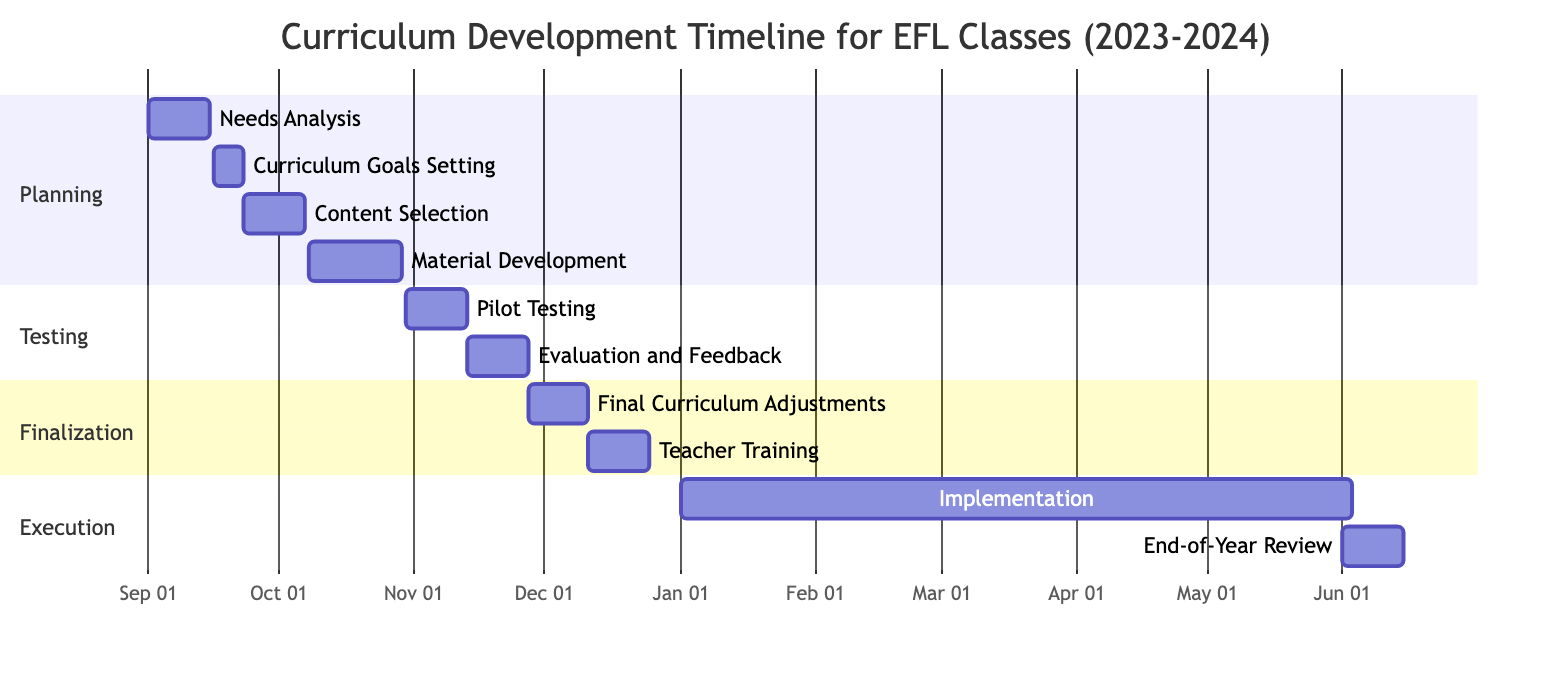What is the duration of the "Content Selection" task? The "Content Selection" task starts on September 23, 2023, and ends on October 7, 2023. This is a duration of 2 weeks.
Answer: 2 weeks When does the "Teacher Training" task begin? The "Teacher Training" task starts on December 11, 2023, according to the timeline.
Answer: December 11, 2023 Which task ends immediately before the "Pilot Testing"? According to the timeline, the "Material Development" task ends on October 29, 2023, which is immediately before the "Pilot Testing" that starts on October 30, 2023.
Answer: Material Development How many weeks are allocated for "Evaluation and Feedback"? The "Evaluation and Feedback" task spans from November 13 to November 26, 2023, which totals 2 weeks.
Answer: 2 weeks What is the total timeframe for the entire curriculum development process, from needs analysis to end-of-year review? The process begins with "Needs Analysis" on September 1, 2023, and ends with "End-of-Year Review" on June 15, 2024. This is a total duration of approximately 9.5 months (9 months and 15 days).
Answer: 9 months and 15 days Is there any overlap between "Material Development" and "Pilot Testing"? "Material Development" ends on October 29, 2023, and "Pilot Testing" begins one day later on October 30, 2023, indicating no overlap; they are sequential tasks.
Answer: No What is the section that contains the "Final Curriculum Adjustments" task? The "Final Curriculum Adjustments" task is located in the "Finalization" section of the Gantt Chart.
Answer: Finalization Which task has the longest duration? The "Implementation" task runs from January 1, 2024, to May 31, 2024, totaling 22 weeks, which is the longest duration compared to other tasks.
Answer: Implementation How many tasks are there in total in the chart? The chart lists 10 tasks in total from "Needs Analysis" to "End-of-Year Review".
Answer: 10 tasks 